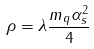Convert formula to latex. <formula><loc_0><loc_0><loc_500><loc_500>\rho = \lambda \frac { m _ { q } \alpha _ { s } ^ { 2 } } { 4 }</formula> 